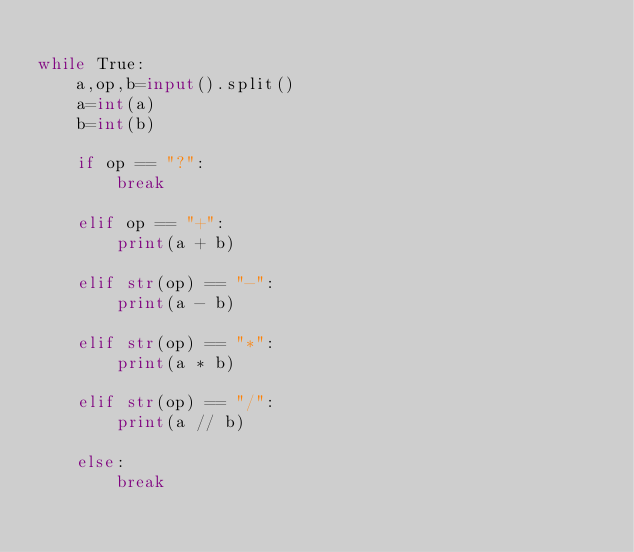Convert code to text. <code><loc_0><loc_0><loc_500><loc_500><_Python_>
while True:
    a,op,b=input().split()
    a=int(a)
    b=int(b)

    if op == "?":
        break

    elif op == "+":
        print(a + b)

    elif str(op) == "-":
        print(a - b)

    elif str(op) == "*":
        print(a * b)

    elif str(op) == "/":
        print(a // b)

    else:
        break
</code> 